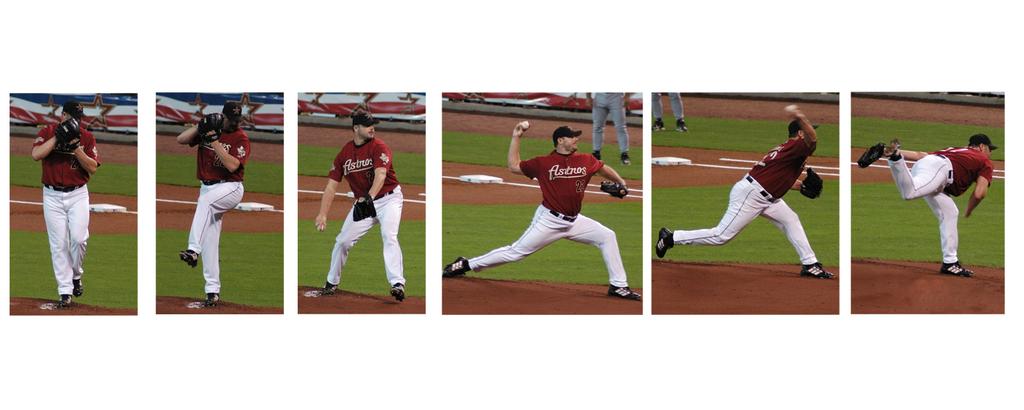What team does this pitcher play for?
Make the answer very short. Astros. 